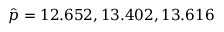<formula> <loc_0><loc_0><loc_500><loc_500>\hat { p } = 1 2 . 6 5 2 , 1 3 . 4 0 2 , 1 3 . 6 1 6</formula> 